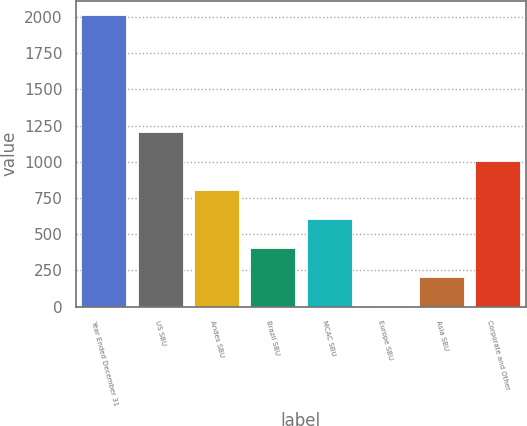Convert chart. <chart><loc_0><loc_0><loc_500><loc_500><bar_chart><fcel>Year Ended December 31<fcel>US SBU<fcel>Andes SBU<fcel>Brazil SBU<fcel>MCAC SBU<fcel>Europe SBU<fcel>Asia SBU<fcel>Corporate and Other<nl><fcel>2012<fcel>1208<fcel>806<fcel>404<fcel>605<fcel>2<fcel>203<fcel>1007<nl></chart> 